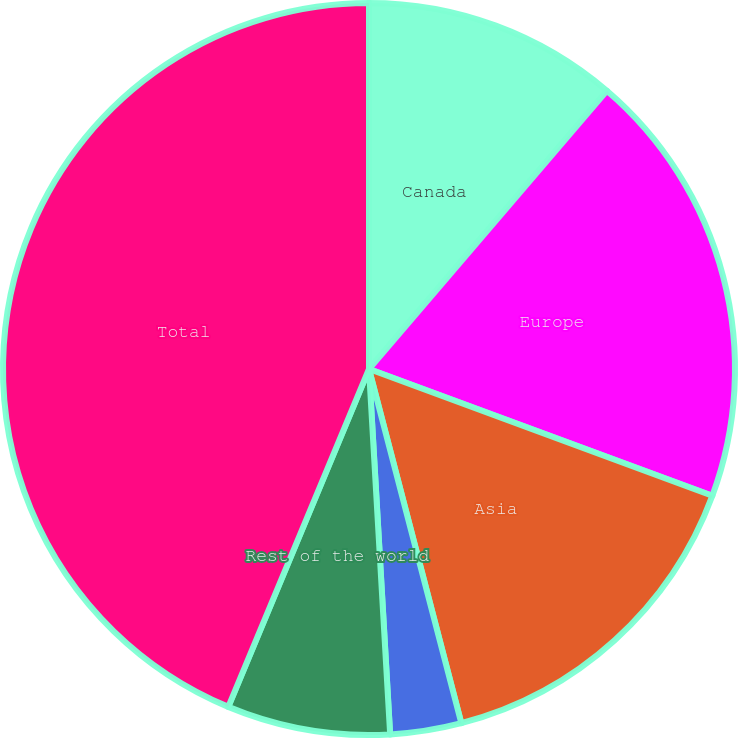Convert chart to OTSL. <chart><loc_0><loc_0><loc_500><loc_500><pie_chart><fcel>Canada<fcel>Europe<fcel>Asia<fcel>Middle East<fcel>Rest of the world<fcel>Total<nl><fcel>11.26%<fcel>19.37%<fcel>15.31%<fcel>3.14%<fcel>7.2%<fcel>43.72%<nl></chart> 